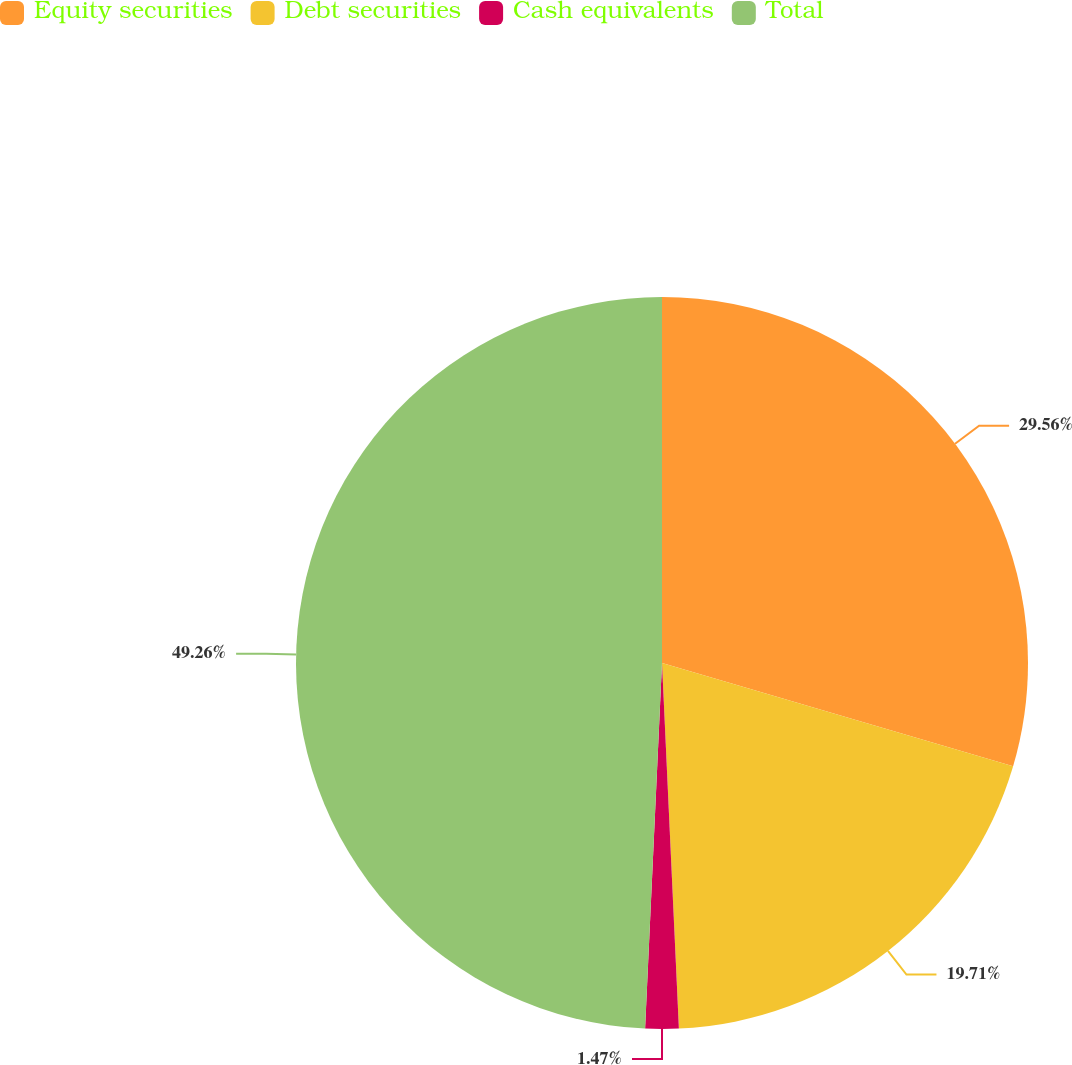<chart> <loc_0><loc_0><loc_500><loc_500><pie_chart><fcel>Equity securities<fcel>Debt securities<fcel>Cash equivalents<fcel>Total<nl><fcel>29.56%<fcel>19.71%<fcel>1.47%<fcel>49.27%<nl></chart> 